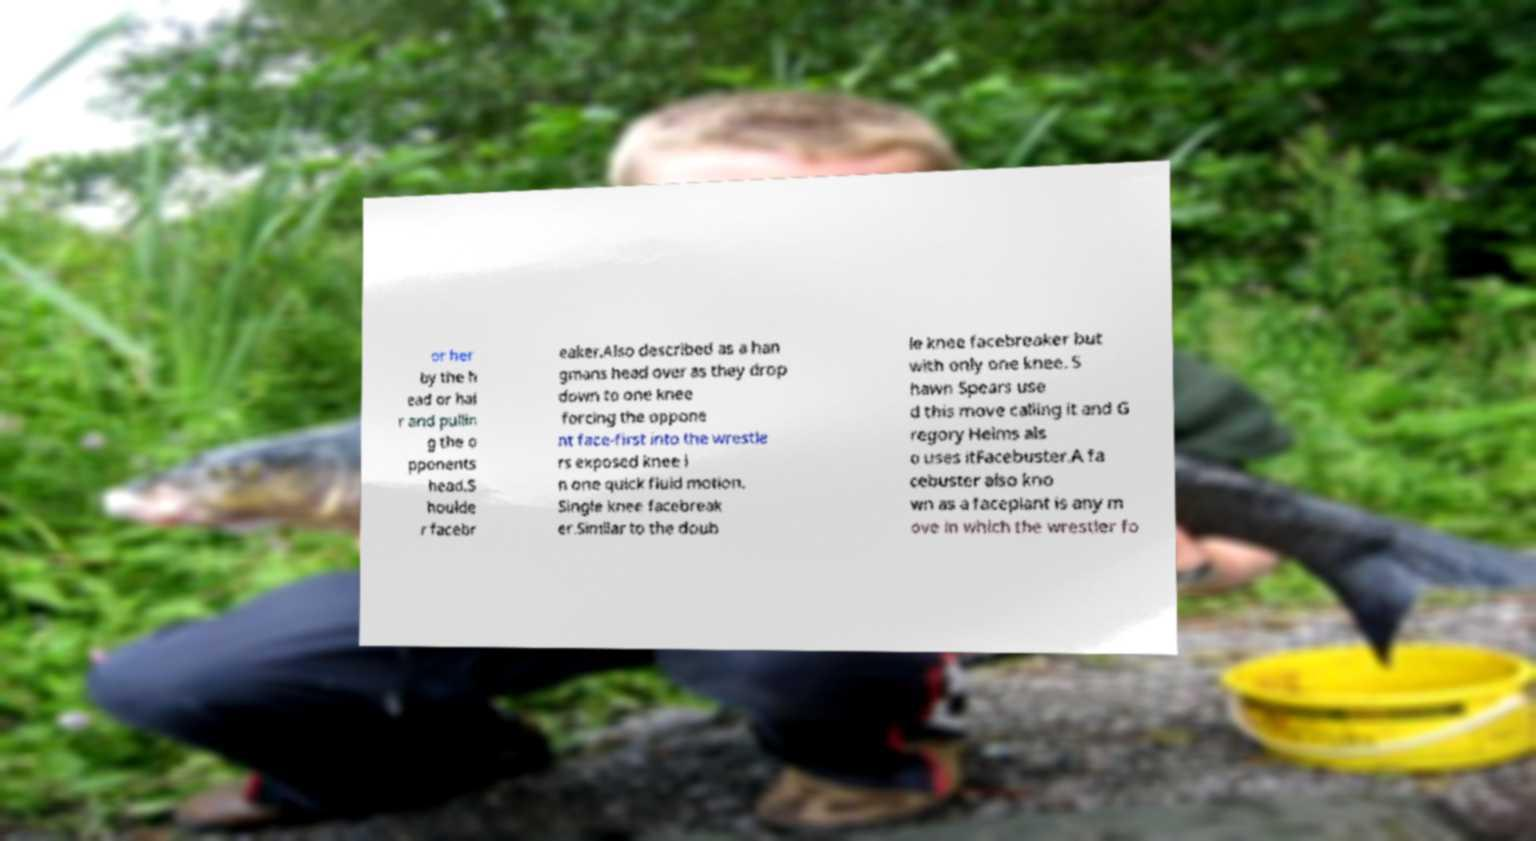Could you assist in decoding the text presented in this image and type it out clearly? or her by the h ead or hai r and pullin g the o pponents head.S houlde r facebr eaker.Also described as a han gmans head over as they drop down to one knee forcing the oppone nt face-first into the wrestle rs exposed knee i n one quick fluid motion. Single knee facebreak er.Similar to the doub le knee facebreaker but with only one knee. S hawn Spears use d this move calling it and G regory Helms als o uses itFacebuster.A fa cebuster also kno wn as a faceplant is any m ove in which the wrestler fo 